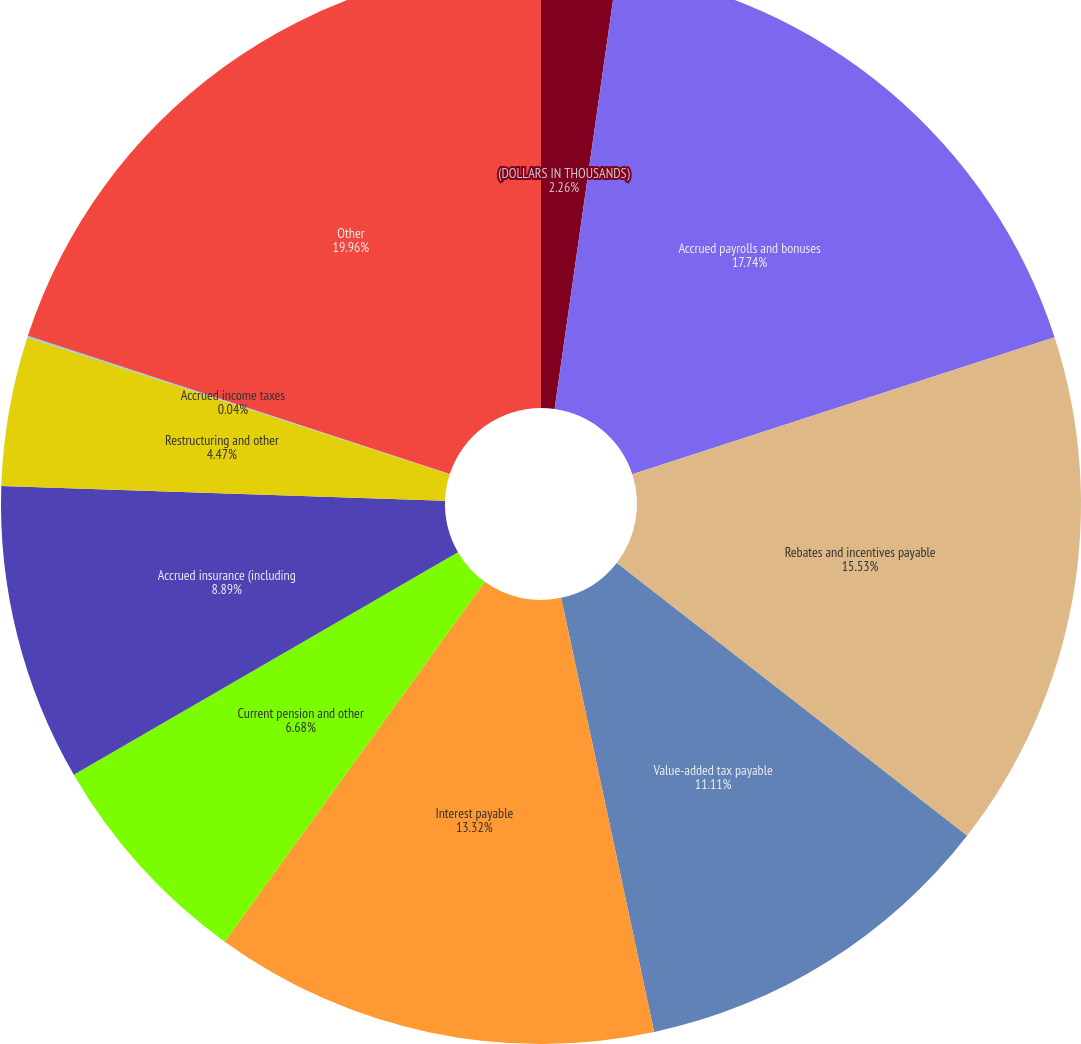<chart> <loc_0><loc_0><loc_500><loc_500><pie_chart><fcel>(DOLLARS IN THOUSANDS)<fcel>Accrued payrolls and bonuses<fcel>Rebates and incentives payable<fcel>Value-added tax payable<fcel>Interest payable<fcel>Current pension and other<fcel>Accrued insurance (including<fcel>Restructuring and other<fcel>Accrued income taxes<fcel>Other<nl><fcel>2.26%<fcel>17.74%<fcel>15.53%<fcel>11.11%<fcel>13.32%<fcel>6.68%<fcel>8.89%<fcel>4.47%<fcel>0.04%<fcel>19.96%<nl></chart> 